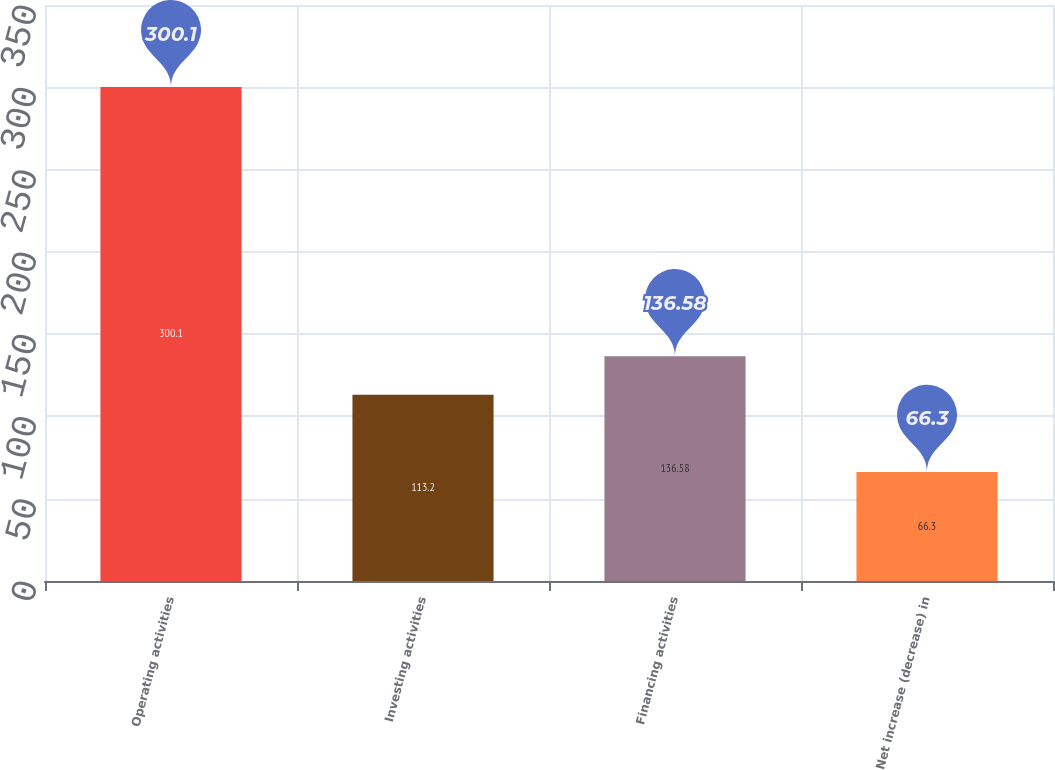Convert chart to OTSL. <chart><loc_0><loc_0><loc_500><loc_500><bar_chart><fcel>Operating activities<fcel>Investing activities<fcel>Financing activities<fcel>Net increase (decrease) in<nl><fcel>300.1<fcel>113.2<fcel>136.58<fcel>66.3<nl></chart> 